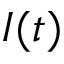Convert formula to latex. <formula><loc_0><loc_0><loc_500><loc_500>I ( t )</formula> 